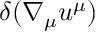<formula> <loc_0><loc_0><loc_500><loc_500>\delta ( \nabla _ { \mu } u ^ { \mu } )</formula> 